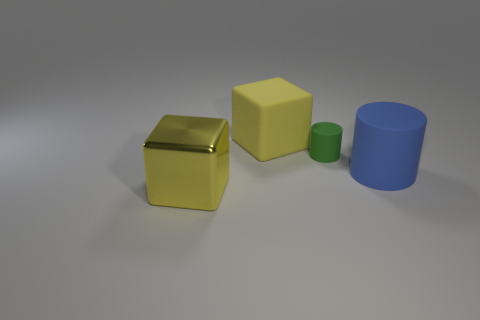There is a matte cube; is it the same color as the large cube in front of the green cylinder?
Make the answer very short. Yes. What is the shape of the big thing that is the same color as the large rubber cube?
Ensure brevity in your answer.  Cube. What material is the large thing to the left of the big thing behind the blue matte cylinder in front of the small green rubber cylinder?
Offer a terse response. Metal. Are there any objects of the same color as the big rubber block?
Offer a terse response. Yes. Are there fewer large cylinders that are behind the small object than large blocks that are in front of the big blue rubber object?
Offer a terse response. Yes. There is another object that is the same shape as the yellow matte object; what is its color?
Provide a succinct answer. Yellow. There is a yellow thing to the right of the yellow shiny thing; is it the same size as the big rubber cylinder?
Provide a short and direct response. Yes. Is the number of yellow cubes that are in front of the big blue rubber cylinder less than the number of blue things?
Offer a very short reply. No. Is there any other thing that is the same size as the green cylinder?
Ensure brevity in your answer.  No. There is a cube in front of the cube to the right of the big yellow shiny block; what size is it?
Offer a terse response. Large. 